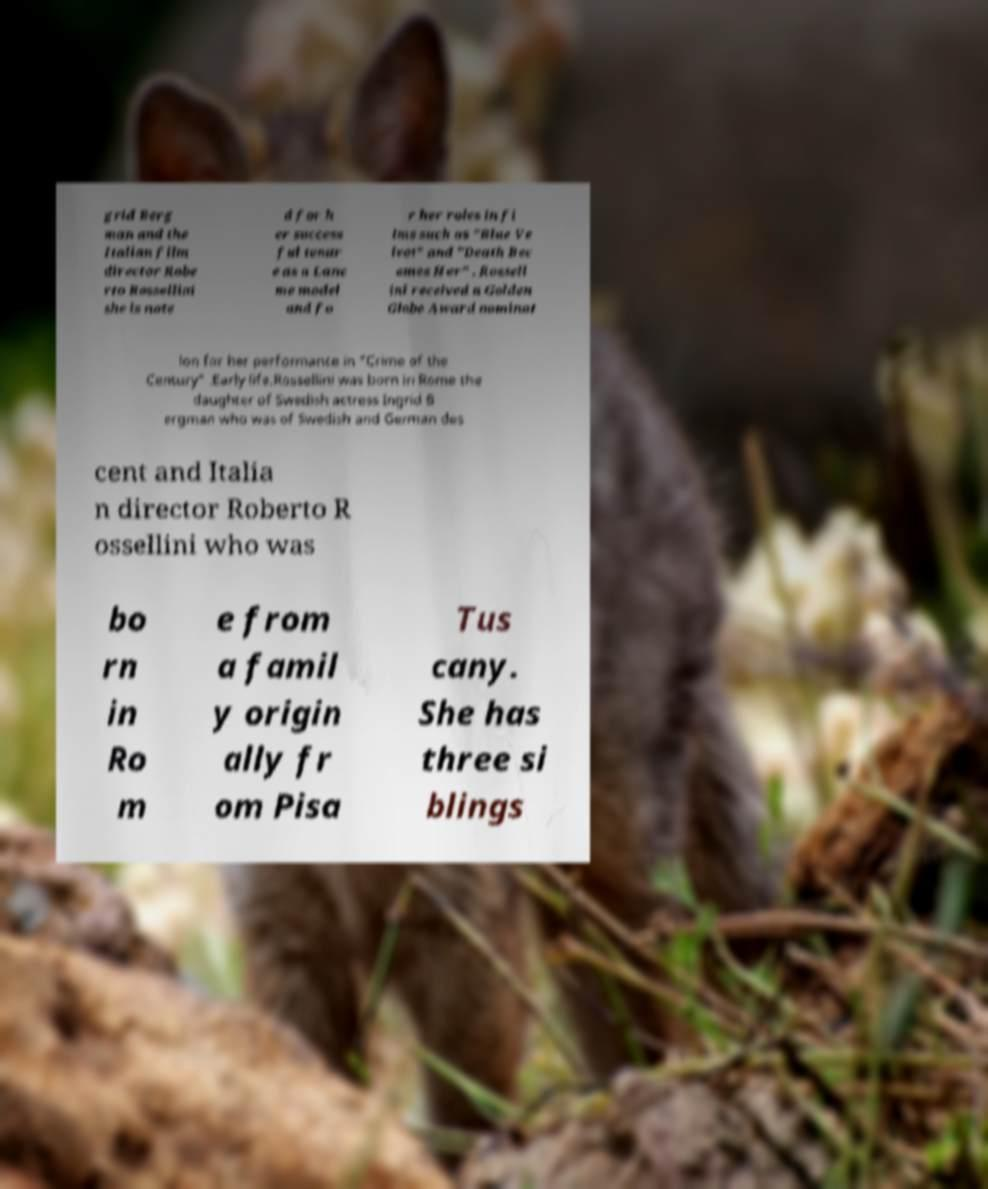For documentation purposes, I need the text within this image transcribed. Could you provide that? grid Berg man and the Italian film director Robe rto Rossellini she is note d for h er success ful tenur e as a Lanc me model and fo r her roles in fi lms such as "Blue Ve lvet" and "Death Bec omes Her" . Rossell ini received a Golden Globe Award nominat ion for her performance in "Crime of the Century" .Early life.Rossellini was born in Rome the daughter of Swedish actress Ingrid B ergman who was of Swedish and German des cent and Italia n director Roberto R ossellini who was bo rn in Ro m e from a famil y origin ally fr om Pisa Tus cany. She has three si blings 